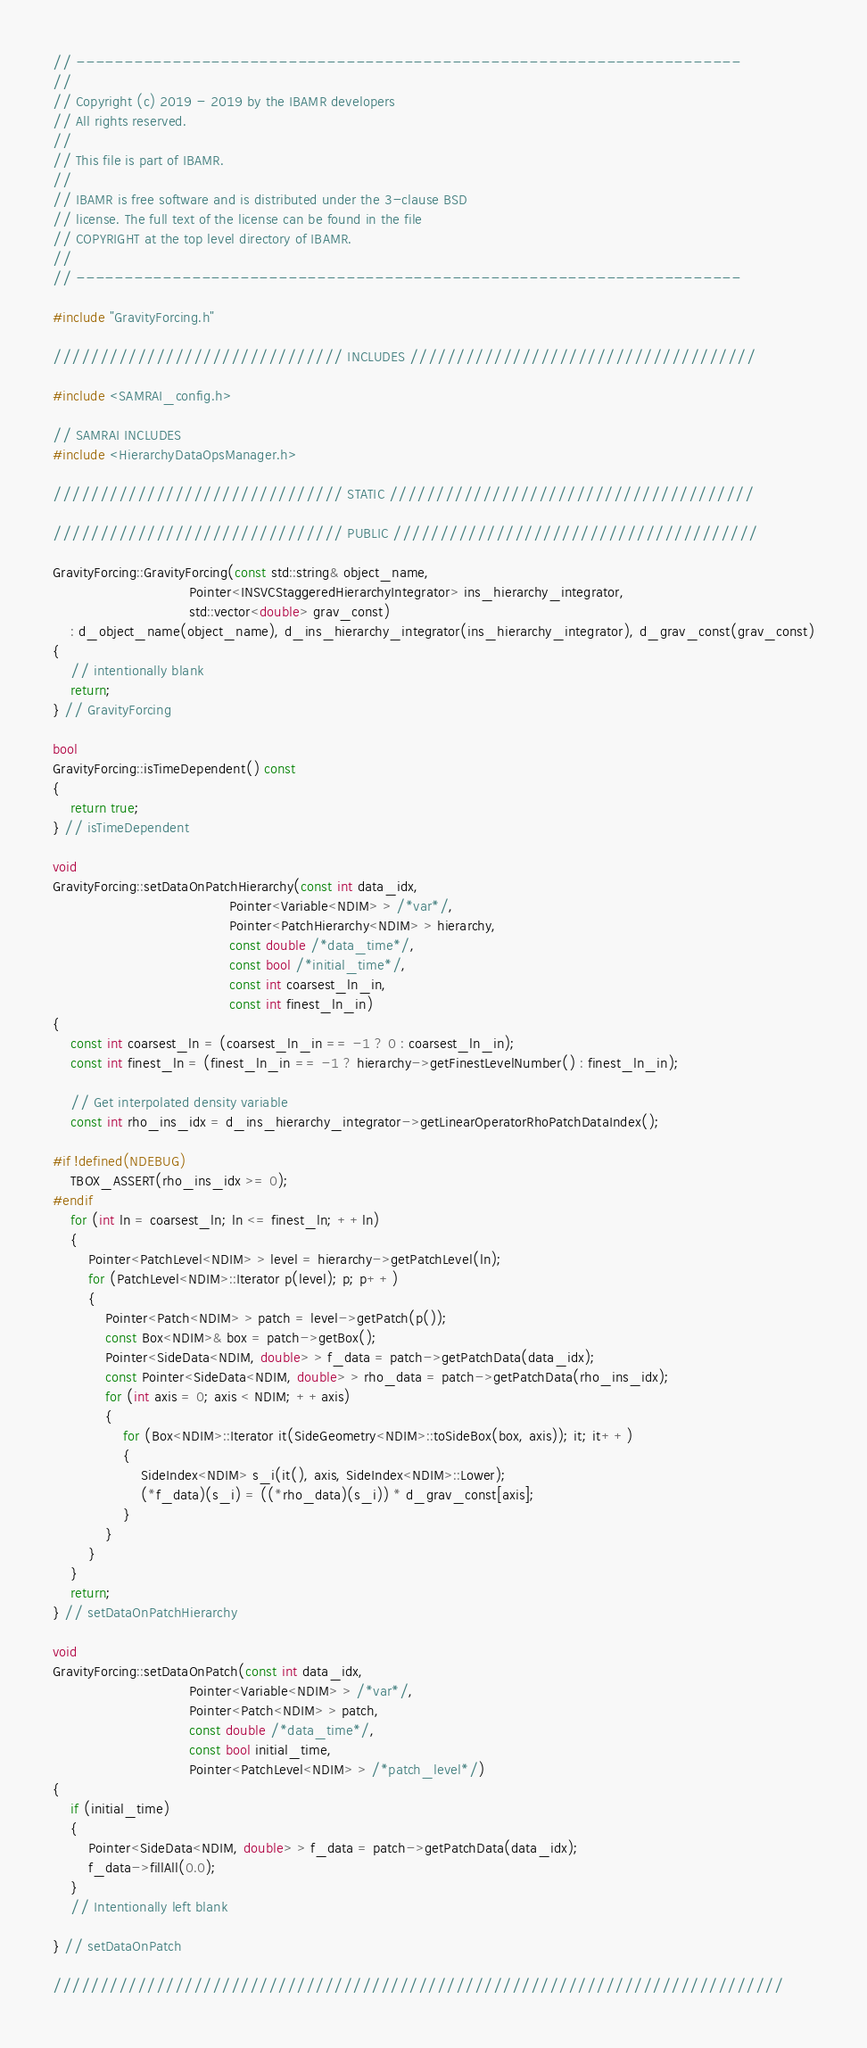<code> <loc_0><loc_0><loc_500><loc_500><_C++_>// ---------------------------------------------------------------------
//
// Copyright (c) 2019 - 2019 by the IBAMR developers
// All rights reserved.
//
// This file is part of IBAMR.
//
// IBAMR is free software and is distributed under the 3-clause BSD
// license. The full text of the license can be found in the file
// COPYRIGHT at the top level directory of IBAMR.
//
// ---------------------------------------------------------------------

#include "GravityForcing.h"

/////////////////////////////// INCLUDES /////////////////////////////////////

#include <SAMRAI_config.h>

// SAMRAI INCLUDES
#include <HierarchyDataOpsManager.h>

/////////////////////////////// STATIC ///////////////////////////////////////

/////////////////////////////// PUBLIC ///////////////////////////////////////

GravityForcing::GravityForcing(const std::string& object_name,
                               Pointer<INSVCStaggeredHierarchyIntegrator> ins_hierarchy_integrator,
                               std::vector<double> grav_const)
    : d_object_name(object_name), d_ins_hierarchy_integrator(ins_hierarchy_integrator), d_grav_const(grav_const)
{
    // intentionally blank
    return;
} // GravityForcing

bool
GravityForcing::isTimeDependent() const
{
    return true;
} // isTimeDependent

void
GravityForcing::setDataOnPatchHierarchy(const int data_idx,
                                        Pointer<Variable<NDIM> > /*var*/,
                                        Pointer<PatchHierarchy<NDIM> > hierarchy,
                                        const double /*data_time*/,
                                        const bool /*initial_time*/,
                                        const int coarsest_ln_in,
                                        const int finest_ln_in)
{
    const int coarsest_ln = (coarsest_ln_in == -1 ? 0 : coarsest_ln_in);
    const int finest_ln = (finest_ln_in == -1 ? hierarchy->getFinestLevelNumber() : finest_ln_in);

    // Get interpolated density variable
    const int rho_ins_idx = d_ins_hierarchy_integrator->getLinearOperatorRhoPatchDataIndex();

#if !defined(NDEBUG)
    TBOX_ASSERT(rho_ins_idx >= 0);
#endif
    for (int ln = coarsest_ln; ln <= finest_ln; ++ln)
    {
        Pointer<PatchLevel<NDIM> > level = hierarchy->getPatchLevel(ln);
        for (PatchLevel<NDIM>::Iterator p(level); p; p++)
        {
            Pointer<Patch<NDIM> > patch = level->getPatch(p());
            const Box<NDIM>& box = patch->getBox();
            Pointer<SideData<NDIM, double> > f_data = patch->getPatchData(data_idx);
            const Pointer<SideData<NDIM, double> > rho_data = patch->getPatchData(rho_ins_idx);
            for (int axis = 0; axis < NDIM; ++axis)
            {
                for (Box<NDIM>::Iterator it(SideGeometry<NDIM>::toSideBox(box, axis)); it; it++)
                {
                    SideIndex<NDIM> s_i(it(), axis, SideIndex<NDIM>::Lower);
                    (*f_data)(s_i) = ((*rho_data)(s_i)) * d_grav_const[axis];
                }
            }
        }
    }
    return;
} // setDataOnPatchHierarchy

void
GravityForcing::setDataOnPatch(const int data_idx,
                               Pointer<Variable<NDIM> > /*var*/,
                               Pointer<Patch<NDIM> > patch,
                               const double /*data_time*/,
                               const bool initial_time,
                               Pointer<PatchLevel<NDIM> > /*patch_level*/)
{
    if (initial_time)
    {
        Pointer<SideData<NDIM, double> > f_data = patch->getPatchData(data_idx);
        f_data->fillAll(0.0);
    }
    // Intentionally left blank

} // setDataOnPatch

//////////////////////////////////////////////////////////////////////////////
</code> 